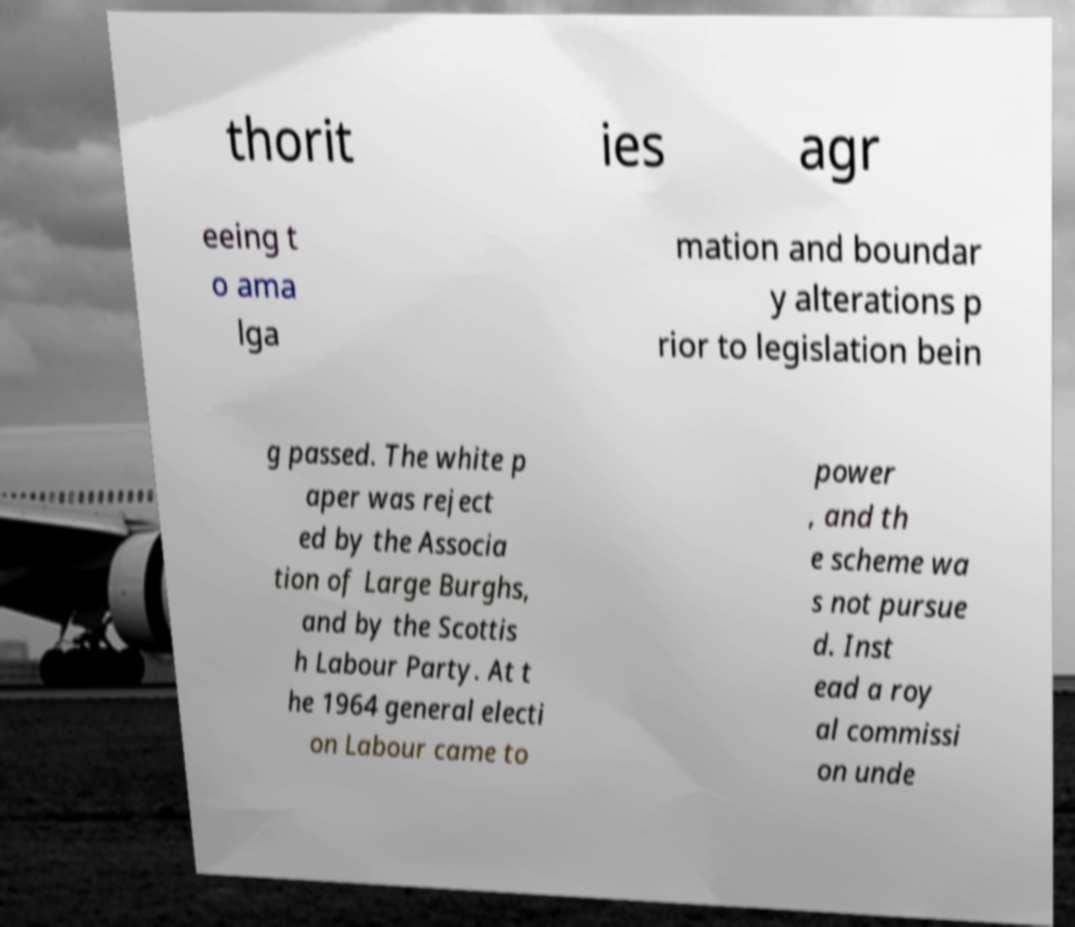For documentation purposes, I need the text within this image transcribed. Could you provide that? thorit ies agr eeing t o ama lga mation and boundar y alterations p rior to legislation bein g passed. The white p aper was reject ed by the Associa tion of Large Burghs, and by the Scottis h Labour Party. At t he 1964 general electi on Labour came to power , and th e scheme wa s not pursue d. Inst ead a roy al commissi on unde 